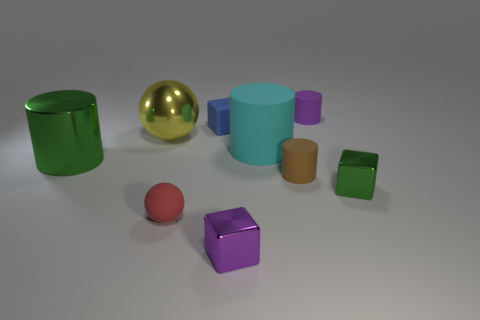What is the material of the big thing that is both to the left of the small blue object and in front of the yellow metal sphere?
Offer a terse response. Metal. Do the brown matte cylinder and the yellow sphere have the same size?
Keep it short and to the point. No. There is a green metal object on the left side of the small cube behind the metallic ball; how big is it?
Your response must be concise. Large. How many tiny objects are both in front of the big shiny sphere and to the left of the purple rubber cylinder?
Make the answer very short. 3. Are there any metallic objects on the right side of the object that is to the left of the sphere to the left of the small red rubber object?
Ensure brevity in your answer.  Yes. What is the shape of the purple matte object that is the same size as the matte sphere?
Ensure brevity in your answer.  Cylinder. Is there a large object of the same color as the large matte cylinder?
Your response must be concise. No. Do the red object and the small brown rubber thing have the same shape?
Provide a succinct answer. No. What number of small objects are purple metal things or cyan rubber cylinders?
Your answer should be compact. 1. There is a big cylinder that is made of the same material as the small sphere; what color is it?
Keep it short and to the point. Cyan. 